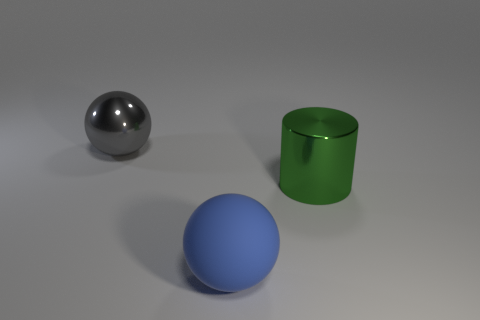Imagine these objects are part of a larger setting; where might they be located? These objects could be situated in a variety of settings. Given their simple and clean appearance, they might be part of a minimalist art installation or used as props in a photography studio for a composition study. 